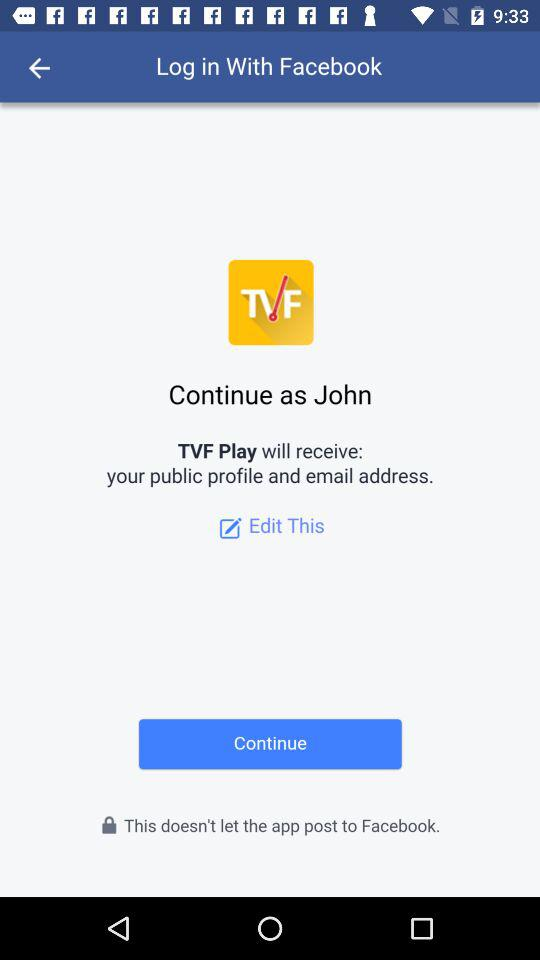What is the application name? The application names are "Facebook" and "TVF Play". 